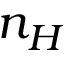Convert formula to latex. <formula><loc_0><loc_0><loc_500><loc_500>n _ { H }</formula> 